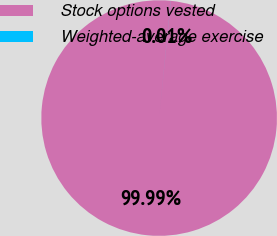<chart> <loc_0><loc_0><loc_500><loc_500><pie_chart><fcel>Stock options vested<fcel>Weighted-average exercise<nl><fcel>99.99%<fcel>0.01%<nl></chart> 